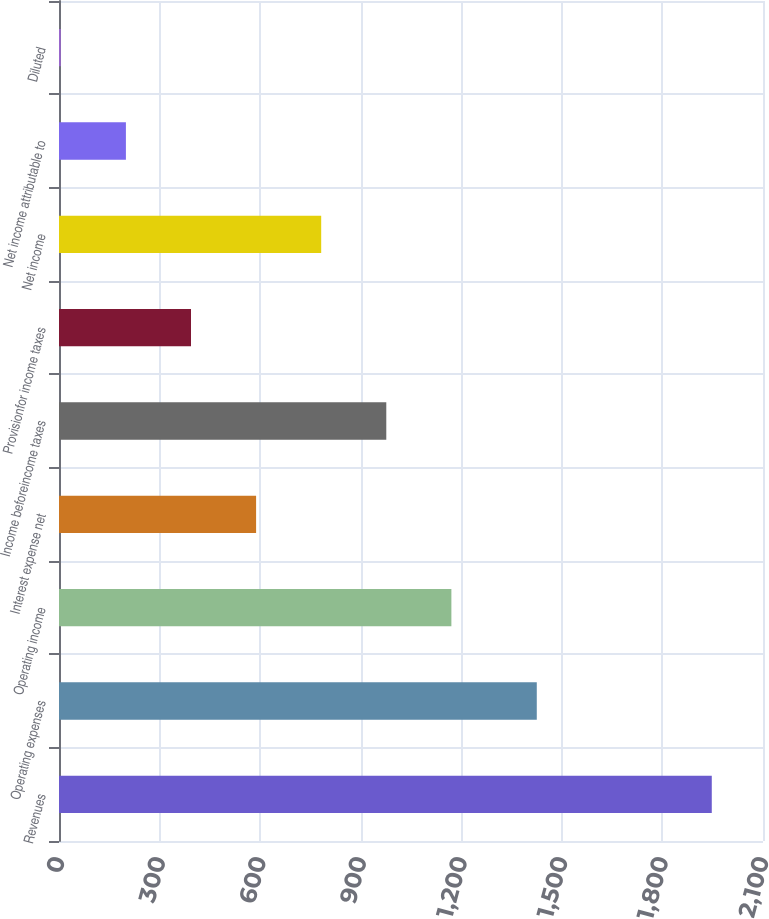<chart> <loc_0><loc_0><loc_500><loc_500><bar_chart><fcel>Revenues<fcel>Operating expenses<fcel>Operating income<fcel>Interest expense net<fcel>Income beforeincome taxes<fcel>Provisionfor income taxes<fcel>Net income<fcel>Net income attributable to<fcel>Diluted<nl><fcel>1947.2<fcel>1425.2<fcel>1170.47<fcel>587.93<fcel>976.29<fcel>393.75<fcel>782.11<fcel>199.57<fcel>5.39<nl></chart> 